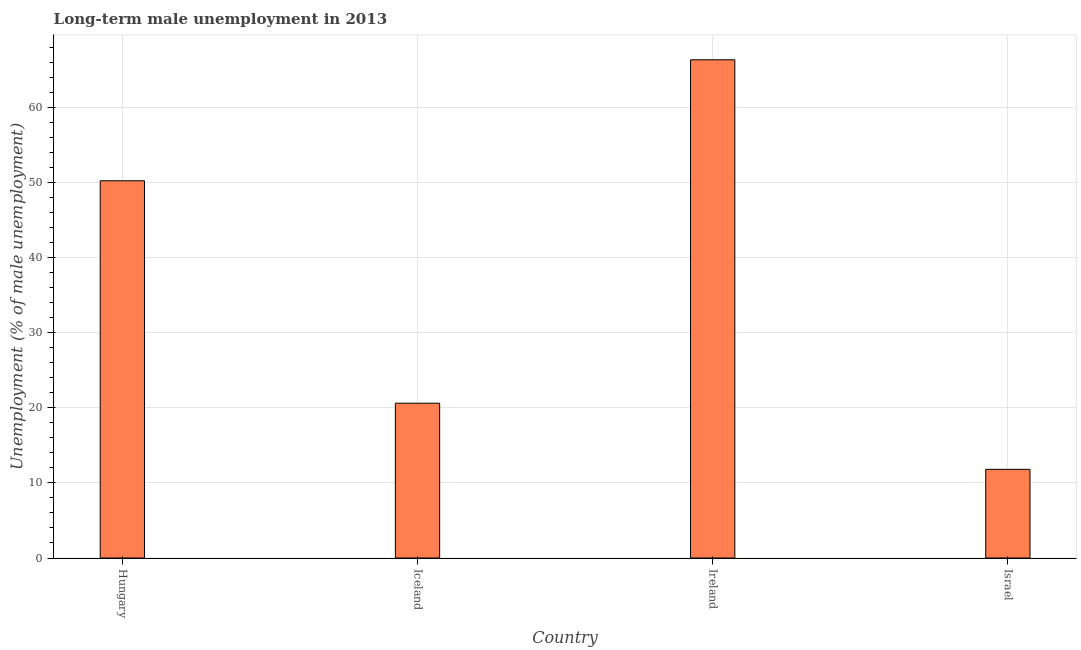What is the title of the graph?
Your response must be concise. Long-term male unemployment in 2013. What is the label or title of the X-axis?
Provide a short and direct response. Country. What is the label or title of the Y-axis?
Provide a short and direct response. Unemployment (% of male unemployment). What is the long-term male unemployment in Ireland?
Offer a very short reply. 66.3. Across all countries, what is the maximum long-term male unemployment?
Provide a succinct answer. 66.3. Across all countries, what is the minimum long-term male unemployment?
Give a very brief answer. 11.8. In which country was the long-term male unemployment maximum?
Provide a short and direct response. Ireland. In which country was the long-term male unemployment minimum?
Provide a short and direct response. Israel. What is the sum of the long-term male unemployment?
Provide a short and direct response. 148.9. What is the difference between the long-term male unemployment in Ireland and Israel?
Offer a terse response. 54.5. What is the average long-term male unemployment per country?
Make the answer very short. 37.23. What is the median long-term male unemployment?
Your response must be concise. 35.4. What is the ratio of the long-term male unemployment in Iceland to that in Ireland?
Your response must be concise. 0.31. Is the long-term male unemployment in Iceland less than that in Ireland?
Your answer should be very brief. Yes. Is the difference between the long-term male unemployment in Ireland and Israel greater than the difference between any two countries?
Make the answer very short. Yes. Is the sum of the long-term male unemployment in Ireland and Israel greater than the maximum long-term male unemployment across all countries?
Make the answer very short. Yes. What is the difference between the highest and the lowest long-term male unemployment?
Ensure brevity in your answer.  54.5. How many bars are there?
Your response must be concise. 4. Are all the bars in the graph horizontal?
Offer a very short reply. No. How many countries are there in the graph?
Your response must be concise. 4. What is the difference between two consecutive major ticks on the Y-axis?
Provide a short and direct response. 10. Are the values on the major ticks of Y-axis written in scientific E-notation?
Your answer should be very brief. No. What is the Unemployment (% of male unemployment) of Hungary?
Your response must be concise. 50.2. What is the Unemployment (% of male unemployment) of Iceland?
Keep it short and to the point. 20.6. What is the Unemployment (% of male unemployment) of Ireland?
Offer a terse response. 66.3. What is the Unemployment (% of male unemployment) in Israel?
Offer a terse response. 11.8. What is the difference between the Unemployment (% of male unemployment) in Hungary and Iceland?
Make the answer very short. 29.6. What is the difference between the Unemployment (% of male unemployment) in Hungary and Ireland?
Your answer should be compact. -16.1. What is the difference between the Unemployment (% of male unemployment) in Hungary and Israel?
Your answer should be compact. 38.4. What is the difference between the Unemployment (% of male unemployment) in Iceland and Ireland?
Your answer should be very brief. -45.7. What is the difference between the Unemployment (% of male unemployment) in Iceland and Israel?
Provide a short and direct response. 8.8. What is the difference between the Unemployment (% of male unemployment) in Ireland and Israel?
Offer a terse response. 54.5. What is the ratio of the Unemployment (% of male unemployment) in Hungary to that in Iceland?
Your answer should be compact. 2.44. What is the ratio of the Unemployment (% of male unemployment) in Hungary to that in Ireland?
Your answer should be compact. 0.76. What is the ratio of the Unemployment (% of male unemployment) in Hungary to that in Israel?
Provide a short and direct response. 4.25. What is the ratio of the Unemployment (% of male unemployment) in Iceland to that in Ireland?
Provide a succinct answer. 0.31. What is the ratio of the Unemployment (% of male unemployment) in Iceland to that in Israel?
Your answer should be very brief. 1.75. What is the ratio of the Unemployment (% of male unemployment) in Ireland to that in Israel?
Your answer should be very brief. 5.62. 